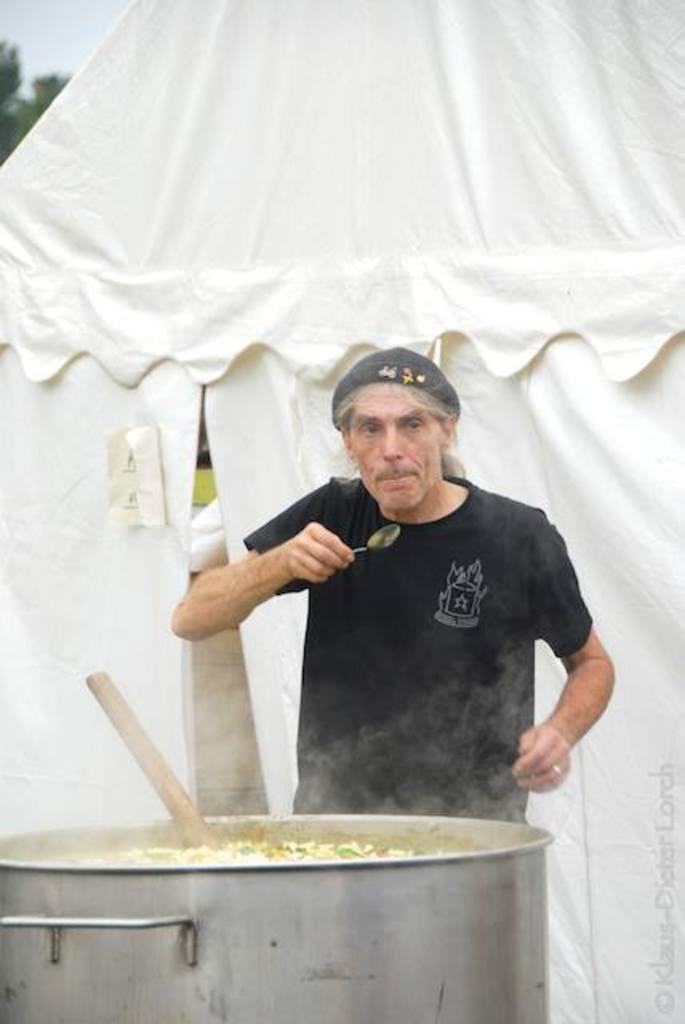Could you give a brief overview of what you see in this image? In this image I can see the person is holding the spoon. In front I can see the food in the big bowl. I can see trees, sky and the white color tint. 